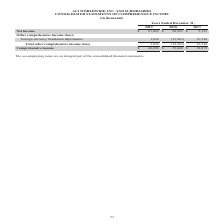According to Aci Worldwide's financial document, What was the net income in 2019? According to the financial document, $67,062 (in thousands). The relevant text states: "Net income $ 67,062 $ 68,921 $ 5,135..." Also, What was the net income in 2017? According to the financial document, $5,135 (in thousands). The relevant text states: "Net income $ 67,062 $ 68,921 $ 5,135..." Also, What was the foreign currency translation adjustments in 2018? Based on the financial document, the answer is -15,261 (in thousands). Also, can you calculate: What was the change in net income between 2018 and 2019? Based on the calculation: $67,062-$68,921, the result is -1859 (in thousands). This is based on the information: "Net income $ 67,062 $ 68,921 $ 5,135 Net income $ 67,062 $ 68,921 $ 5,135..." The key data points involved are: 67,062, 68,921. Also, can you calculate: What was the change in comprehensive income between 2018 and 2019? Based on the calculation: $68,096-$53,660, the result is 14436 (in thousands). This is based on the information: "Comprehensive income $ 68,096 $ 53,660 $ 21,879 Comprehensive income $ 68,096 $ 53,660 $ 21,879..." The key data points involved are: 53,660, 68,096. Also, can you calculate: What was the percentage change in comprehensive income between 2017 and 2018? To answer this question, I need to perform calculations using the financial data. The calculation is: ($53,660-$21,879)/$21,879, which equals 145.26 (percentage). This is based on the information: "Comprehensive income $ 68,096 $ 53,660 $ 21,879 Comprehensive income $ 68,096 $ 53,660 $ 21,879..." The key data points involved are: 21,879, 53,660. 